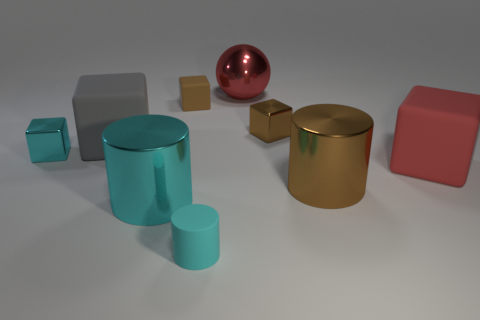What material is the big cube that is the same color as the ball?
Provide a short and direct response. Rubber. How big is the shiny ball?
Your response must be concise. Large. There is a cyan cylinder that is the same size as the red ball; what is its material?
Keep it short and to the point. Metal. What color is the large block in front of the big gray thing?
Give a very brief answer. Red. What number of large gray metal spheres are there?
Offer a terse response. 0. Is there a sphere behind the metallic cylinder that is left of the large red object on the left side of the small brown shiny cube?
Give a very brief answer. Yes. What shape is the brown object that is the same size as the red cube?
Give a very brief answer. Cylinder. How many other objects are the same color as the matte cylinder?
Your answer should be compact. 2. What material is the small cylinder?
Offer a very short reply. Rubber. What number of other things are there of the same material as the small cylinder
Offer a terse response. 3. 